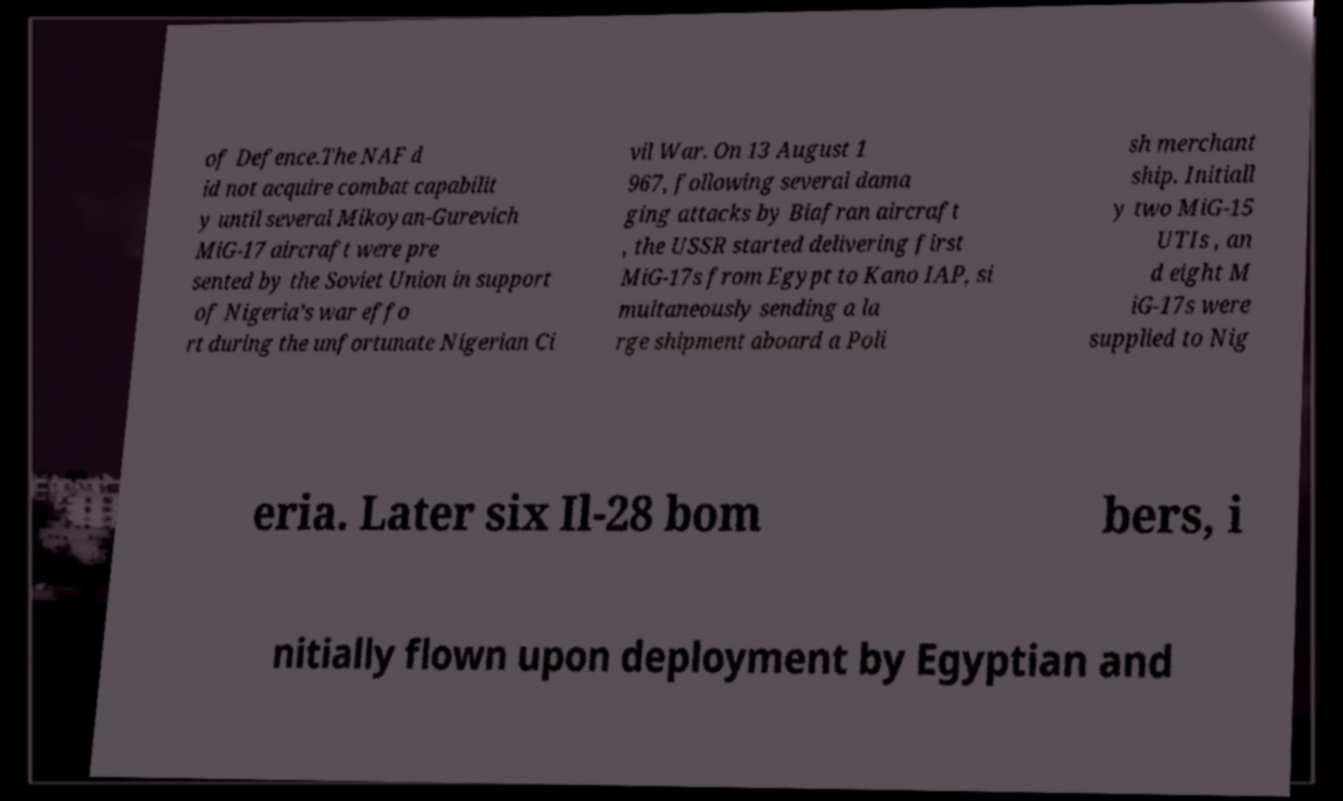What messages or text are displayed in this image? I need them in a readable, typed format. of Defence.The NAF d id not acquire combat capabilit y until several Mikoyan-Gurevich MiG-17 aircraft were pre sented by the Soviet Union in support of Nigeria’s war effo rt during the unfortunate Nigerian Ci vil War. On 13 August 1 967, following several dama ging attacks by Biafran aircraft , the USSR started delivering first MiG-17s from Egypt to Kano IAP, si multaneously sending a la rge shipment aboard a Poli sh merchant ship. Initiall y two MiG-15 UTIs , an d eight M iG-17s were supplied to Nig eria. Later six Il-28 bom bers, i nitially flown upon deployment by Egyptian and 